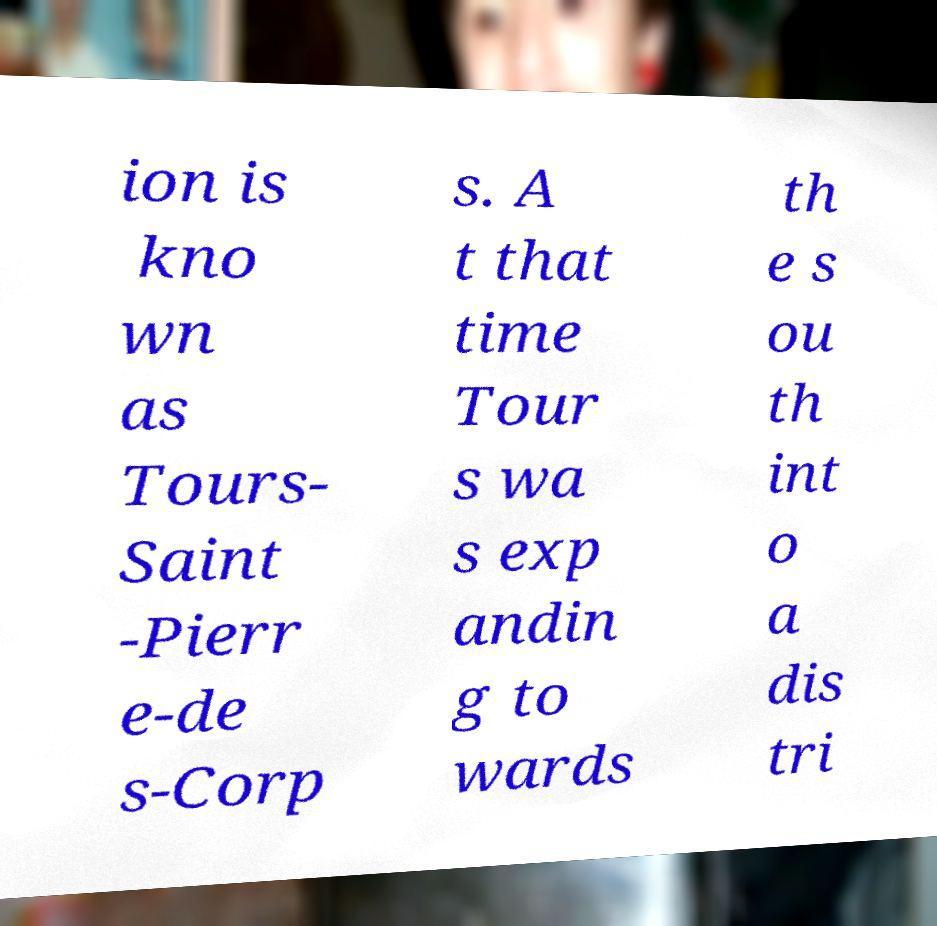Could you extract and type out the text from this image? ion is kno wn as Tours- Saint -Pierr e-de s-Corp s. A t that time Tour s wa s exp andin g to wards th e s ou th int o a dis tri 